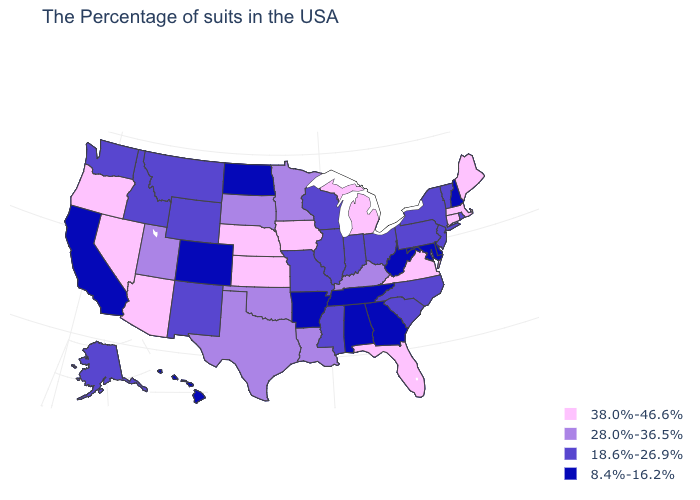Among the states that border Virginia , which have the highest value?
Write a very short answer. Kentucky. What is the value of Massachusetts?
Short answer required. 38.0%-46.6%. Name the states that have a value in the range 8.4%-16.2%?
Give a very brief answer. New Hampshire, Delaware, Maryland, West Virginia, Georgia, Alabama, Tennessee, Arkansas, North Dakota, Colorado, California, Hawaii. Name the states that have a value in the range 8.4%-16.2%?
Short answer required. New Hampshire, Delaware, Maryland, West Virginia, Georgia, Alabama, Tennessee, Arkansas, North Dakota, Colorado, California, Hawaii. What is the lowest value in the Northeast?
Keep it brief. 8.4%-16.2%. Does Delaware have a lower value than Arkansas?
Concise answer only. No. Does the map have missing data?
Be succinct. No. Name the states that have a value in the range 38.0%-46.6%?
Write a very short answer. Maine, Massachusetts, Connecticut, Virginia, Florida, Michigan, Iowa, Kansas, Nebraska, Arizona, Nevada, Oregon. What is the lowest value in states that border Minnesota?
Answer briefly. 8.4%-16.2%. Which states have the lowest value in the USA?
Answer briefly. New Hampshire, Delaware, Maryland, West Virginia, Georgia, Alabama, Tennessee, Arkansas, North Dakota, Colorado, California, Hawaii. What is the value of New Jersey?
Answer briefly. 18.6%-26.9%. Name the states that have a value in the range 8.4%-16.2%?
Short answer required. New Hampshire, Delaware, Maryland, West Virginia, Georgia, Alabama, Tennessee, Arkansas, North Dakota, Colorado, California, Hawaii. Does New Mexico have the lowest value in the USA?
Give a very brief answer. No. Does South Carolina have a higher value than Delaware?
Quick response, please. Yes. 